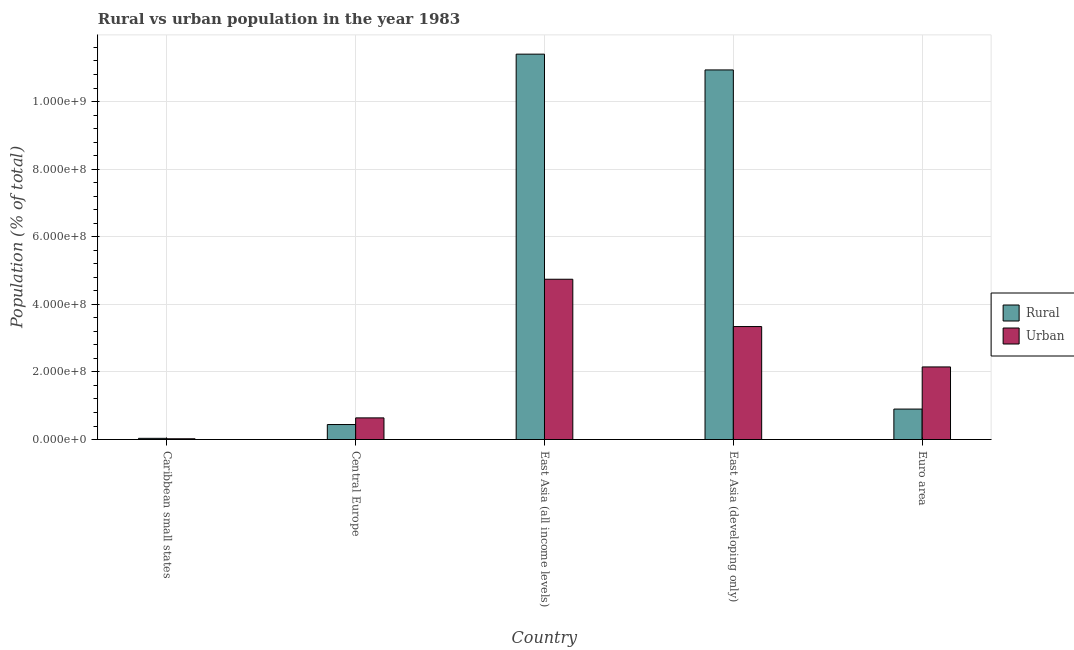How many different coloured bars are there?
Your response must be concise. 2. How many groups of bars are there?
Your response must be concise. 5. What is the label of the 4th group of bars from the left?
Your answer should be compact. East Asia (developing only). In how many cases, is the number of bars for a given country not equal to the number of legend labels?
Provide a short and direct response. 0. What is the urban population density in Caribbean small states?
Provide a short and direct response. 2.19e+06. Across all countries, what is the maximum urban population density?
Make the answer very short. 4.74e+08. Across all countries, what is the minimum urban population density?
Make the answer very short. 2.19e+06. In which country was the rural population density maximum?
Make the answer very short. East Asia (all income levels). In which country was the rural population density minimum?
Keep it short and to the point. Caribbean small states. What is the total urban population density in the graph?
Make the answer very short. 1.09e+09. What is the difference between the rural population density in Central Europe and that in Euro area?
Offer a very short reply. -4.58e+07. What is the difference between the rural population density in East Asia (developing only) and the urban population density in Caribbean small states?
Give a very brief answer. 1.09e+09. What is the average rural population density per country?
Your answer should be very brief. 4.74e+08. What is the difference between the rural population density and urban population density in East Asia (developing only)?
Provide a short and direct response. 7.59e+08. In how many countries, is the rural population density greater than 160000000 %?
Make the answer very short. 2. What is the ratio of the urban population density in Caribbean small states to that in Central Europe?
Provide a succinct answer. 0.03. Is the difference between the rural population density in Caribbean small states and Euro area greater than the difference between the urban population density in Caribbean small states and Euro area?
Ensure brevity in your answer.  Yes. What is the difference between the highest and the second highest urban population density?
Offer a terse response. 1.40e+08. What is the difference between the highest and the lowest urban population density?
Offer a very short reply. 4.72e+08. Is the sum of the urban population density in Caribbean small states and Euro area greater than the maximum rural population density across all countries?
Your answer should be compact. No. What does the 1st bar from the left in Caribbean small states represents?
Your response must be concise. Rural. What does the 2nd bar from the right in Euro area represents?
Provide a succinct answer. Rural. How many bars are there?
Provide a succinct answer. 10. How many countries are there in the graph?
Ensure brevity in your answer.  5. Does the graph contain grids?
Offer a terse response. Yes. How many legend labels are there?
Provide a succinct answer. 2. How are the legend labels stacked?
Keep it short and to the point. Vertical. What is the title of the graph?
Provide a succinct answer. Rural vs urban population in the year 1983. Does "Agricultural land" appear as one of the legend labels in the graph?
Provide a short and direct response. No. What is the label or title of the X-axis?
Ensure brevity in your answer.  Country. What is the label or title of the Y-axis?
Give a very brief answer. Population (% of total). What is the Population (% of total) of Rural in Caribbean small states?
Your answer should be very brief. 3.48e+06. What is the Population (% of total) of Urban in Caribbean small states?
Provide a succinct answer. 2.19e+06. What is the Population (% of total) in Rural in Central Europe?
Provide a succinct answer. 4.43e+07. What is the Population (% of total) in Urban in Central Europe?
Offer a terse response. 6.40e+07. What is the Population (% of total) in Rural in East Asia (all income levels)?
Offer a very short reply. 1.14e+09. What is the Population (% of total) in Urban in East Asia (all income levels)?
Provide a short and direct response. 4.74e+08. What is the Population (% of total) in Rural in East Asia (developing only)?
Keep it short and to the point. 1.09e+09. What is the Population (% of total) of Urban in East Asia (developing only)?
Your answer should be very brief. 3.34e+08. What is the Population (% of total) in Rural in Euro area?
Your answer should be very brief. 9.01e+07. What is the Population (% of total) of Urban in Euro area?
Keep it short and to the point. 2.15e+08. Across all countries, what is the maximum Population (% of total) in Rural?
Ensure brevity in your answer.  1.14e+09. Across all countries, what is the maximum Population (% of total) in Urban?
Your response must be concise. 4.74e+08. Across all countries, what is the minimum Population (% of total) in Rural?
Ensure brevity in your answer.  3.48e+06. Across all countries, what is the minimum Population (% of total) of Urban?
Ensure brevity in your answer.  2.19e+06. What is the total Population (% of total) in Rural in the graph?
Offer a terse response. 2.37e+09. What is the total Population (% of total) of Urban in the graph?
Keep it short and to the point. 1.09e+09. What is the difference between the Population (% of total) of Rural in Caribbean small states and that in Central Europe?
Give a very brief answer. -4.08e+07. What is the difference between the Population (% of total) in Urban in Caribbean small states and that in Central Europe?
Make the answer very short. -6.18e+07. What is the difference between the Population (% of total) in Rural in Caribbean small states and that in East Asia (all income levels)?
Offer a very short reply. -1.14e+09. What is the difference between the Population (% of total) of Urban in Caribbean small states and that in East Asia (all income levels)?
Offer a terse response. -4.72e+08. What is the difference between the Population (% of total) of Rural in Caribbean small states and that in East Asia (developing only)?
Provide a succinct answer. -1.09e+09. What is the difference between the Population (% of total) in Urban in Caribbean small states and that in East Asia (developing only)?
Offer a terse response. -3.32e+08. What is the difference between the Population (% of total) of Rural in Caribbean small states and that in Euro area?
Your answer should be compact. -8.66e+07. What is the difference between the Population (% of total) in Urban in Caribbean small states and that in Euro area?
Your answer should be very brief. -2.13e+08. What is the difference between the Population (% of total) of Rural in Central Europe and that in East Asia (all income levels)?
Ensure brevity in your answer.  -1.10e+09. What is the difference between the Population (% of total) of Urban in Central Europe and that in East Asia (all income levels)?
Provide a short and direct response. -4.10e+08. What is the difference between the Population (% of total) of Rural in Central Europe and that in East Asia (developing only)?
Your answer should be very brief. -1.05e+09. What is the difference between the Population (% of total) in Urban in Central Europe and that in East Asia (developing only)?
Ensure brevity in your answer.  -2.70e+08. What is the difference between the Population (% of total) in Rural in Central Europe and that in Euro area?
Provide a short and direct response. -4.58e+07. What is the difference between the Population (% of total) of Urban in Central Europe and that in Euro area?
Offer a terse response. -1.51e+08. What is the difference between the Population (% of total) in Rural in East Asia (all income levels) and that in East Asia (developing only)?
Your response must be concise. 4.67e+07. What is the difference between the Population (% of total) of Urban in East Asia (all income levels) and that in East Asia (developing only)?
Keep it short and to the point. 1.40e+08. What is the difference between the Population (% of total) of Rural in East Asia (all income levels) and that in Euro area?
Provide a short and direct response. 1.05e+09. What is the difference between the Population (% of total) of Urban in East Asia (all income levels) and that in Euro area?
Ensure brevity in your answer.  2.59e+08. What is the difference between the Population (% of total) of Rural in East Asia (developing only) and that in Euro area?
Give a very brief answer. 1.00e+09. What is the difference between the Population (% of total) of Urban in East Asia (developing only) and that in Euro area?
Your answer should be very brief. 1.19e+08. What is the difference between the Population (% of total) in Rural in Caribbean small states and the Population (% of total) in Urban in Central Europe?
Your answer should be compact. -6.05e+07. What is the difference between the Population (% of total) of Rural in Caribbean small states and the Population (% of total) of Urban in East Asia (all income levels)?
Offer a terse response. -4.71e+08. What is the difference between the Population (% of total) of Rural in Caribbean small states and the Population (% of total) of Urban in East Asia (developing only)?
Provide a succinct answer. -3.31e+08. What is the difference between the Population (% of total) in Rural in Caribbean small states and the Population (% of total) in Urban in Euro area?
Offer a terse response. -2.11e+08. What is the difference between the Population (% of total) in Rural in Central Europe and the Population (% of total) in Urban in East Asia (all income levels)?
Give a very brief answer. -4.30e+08. What is the difference between the Population (% of total) of Rural in Central Europe and the Population (% of total) of Urban in East Asia (developing only)?
Give a very brief answer. -2.90e+08. What is the difference between the Population (% of total) in Rural in Central Europe and the Population (% of total) in Urban in Euro area?
Provide a short and direct response. -1.70e+08. What is the difference between the Population (% of total) in Rural in East Asia (all income levels) and the Population (% of total) in Urban in East Asia (developing only)?
Your answer should be very brief. 8.06e+08. What is the difference between the Population (% of total) of Rural in East Asia (all income levels) and the Population (% of total) of Urban in Euro area?
Your answer should be compact. 9.26e+08. What is the difference between the Population (% of total) in Rural in East Asia (developing only) and the Population (% of total) in Urban in Euro area?
Offer a very short reply. 8.79e+08. What is the average Population (% of total) of Rural per country?
Your answer should be compact. 4.74e+08. What is the average Population (% of total) of Urban per country?
Give a very brief answer. 2.18e+08. What is the difference between the Population (% of total) in Rural and Population (% of total) in Urban in Caribbean small states?
Your answer should be very brief. 1.29e+06. What is the difference between the Population (% of total) of Rural and Population (% of total) of Urban in Central Europe?
Your answer should be compact. -1.97e+07. What is the difference between the Population (% of total) in Rural and Population (% of total) in Urban in East Asia (all income levels)?
Give a very brief answer. 6.66e+08. What is the difference between the Population (% of total) of Rural and Population (% of total) of Urban in East Asia (developing only)?
Keep it short and to the point. 7.59e+08. What is the difference between the Population (% of total) of Rural and Population (% of total) of Urban in Euro area?
Ensure brevity in your answer.  -1.25e+08. What is the ratio of the Population (% of total) of Rural in Caribbean small states to that in Central Europe?
Ensure brevity in your answer.  0.08. What is the ratio of the Population (% of total) of Urban in Caribbean small states to that in Central Europe?
Give a very brief answer. 0.03. What is the ratio of the Population (% of total) in Rural in Caribbean small states to that in East Asia (all income levels)?
Ensure brevity in your answer.  0. What is the ratio of the Population (% of total) of Urban in Caribbean small states to that in East Asia (all income levels)?
Offer a terse response. 0. What is the ratio of the Population (% of total) of Rural in Caribbean small states to that in East Asia (developing only)?
Ensure brevity in your answer.  0. What is the ratio of the Population (% of total) of Urban in Caribbean small states to that in East Asia (developing only)?
Ensure brevity in your answer.  0.01. What is the ratio of the Population (% of total) in Rural in Caribbean small states to that in Euro area?
Keep it short and to the point. 0.04. What is the ratio of the Population (% of total) of Urban in Caribbean small states to that in Euro area?
Offer a terse response. 0.01. What is the ratio of the Population (% of total) of Rural in Central Europe to that in East Asia (all income levels)?
Your answer should be compact. 0.04. What is the ratio of the Population (% of total) in Urban in Central Europe to that in East Asia (all income levels)?
Ensure brevity in your answer.  0.14. What is the ratio of the Population (% of total) of Rural in Central Europe to that in East Asia (developing only)?
Ensure brevity in your answer.  0.04. What is the ratio of the Population (% of total) of Urban in Central Europe to that in East Asia (developing only)?
Provide a succinct answer. 0.19. What is the ratio of the Population (% of total) of Rural in Central Europe to that in Euro area?
Make the answer very short. 0.49. What is the ratio of the Population (% of total) in Urban in Central Europe to that in Euro area?
Your answer should be compact. 0.3. What is the ratio of the Population (% of total) in Rural in East Asia (all income levels) to that in East Asia (developing only)?
Give a very brief answer. 1.04. What is the ratio of the Population (% of total) of Urban in East Asia (all income levels) to that in East Asia (developing only)?
Make the answer very short. 1.42. What is the ratio of the Population (% of total) in Rural in East Asia (all income levels) to that in Euro area?
Your response must be concise. 12.65. What is the ratio of the Population (% of total) in Urban in East Asia (all income levels) to that in Euro area?
Ensure brevity in your answer.  2.21. What is the ratio of the Population (% of total) in Rural in East Asia (developing only) to that in Euro area?
Your answer should be very brief. 12.14. What is the ratio of the Population (% of total) in Urban in East Asia (developing only) to that in Euro area?
Make the answer very short. 1.56. What is the difference between the highest and the second highest Population (% of total) of Rural?
Give a very brief answer. 4.67e+07. What is the difference between the highest and the second highest Population (% of total) of Urban?
Make the answer very short. 1.40e+08. What is the difference between the highest and the lowest Population (% of total) of Rural?
Make the answer very short. 1.14e+09. What is the difference between the highest and the lowest Population (% of total) in Urban?
Make the answer very short. 4.72e+08. 